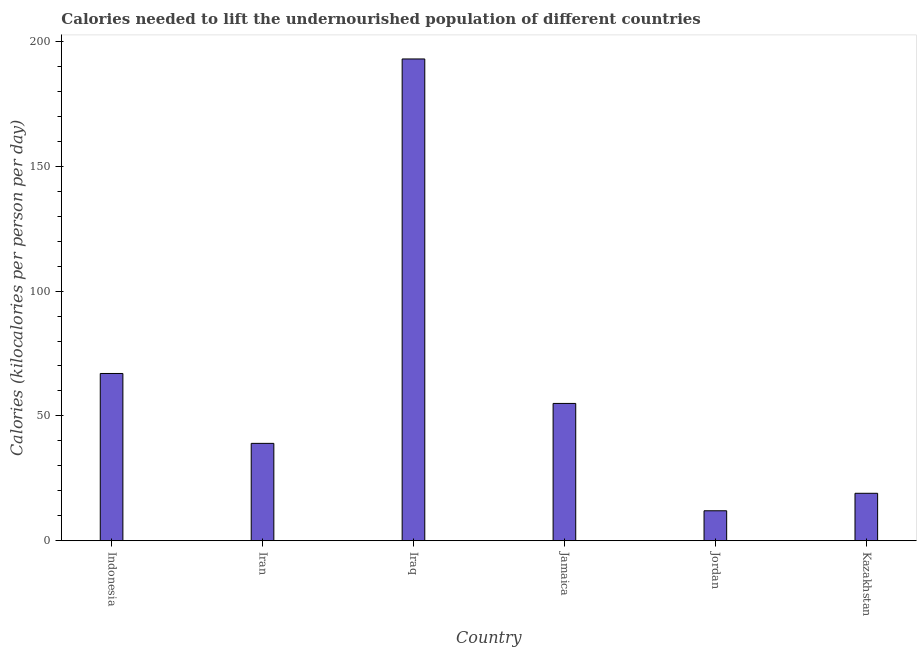What is the title of the graph?
Your answer should be compact. Calories needed to lift the undernourished population of different countries. What is the label or title of the X-axis?
Your answer should be very brief. Country. What is the label or title of the Y-axis?
Make the answer very short. Calories (kilocalories per person per day). What is the depth of food deficit in Jordan?
Your answer should be compact. 12. Across all countries, what is the maximum depth of food deficit?
Provide a succinct answer. 193. Across all countries, what is the minimum depth of food deficit?
Provide a short and direct response. 12. In which country was the depth of food deficit maximum?
Offer a terse response. Iraq. In which country was the depth of food deficit minimum?
Give a very brief answer. Jordan. What is the sum of the depth of food deficit?
Your answer should be compact. 385. What is the average depth of food deficit per country?
Your response must be concise. 64.17. What is the ratio of the depth of food deficit in Iraq to that in Kazakhstan?
Keep it short and to the point. 10.16. Is the depth of food deficit in Indonesia less than that in Iraq?
Make the answer very short. Yes. What is the difference between the highest and the second highest depth of food deficit?
Your answer should be very brief. 126. Is the sum of the depth of food deficit in Iraq and Jamaica greater than the maximum depth of food deficit across all countries?
Provide a short and direct response. Yes. What is the difference between the highest and the lowest depth of food deficit?
Your answer should be compact. 181. In how many countries, is the depth of food deficit greater than the average depth of food deficit taken over all countries?
Provide a succinct answer. 2. How many countries are there in the graph?
Your answer should be very brief. 6. Are the values on the major ticks of Y-axis written in scientific E-notation?
Provide a succinct answer. No. What is the Calories (kilocalories per person per day) of Indonesia?
Provide a short and direct response. 67. What is the Calories (kilocalories per person per day) of Iran?
Provide a short and direct response. 39. What is the Calories (kilocalories per person per day) of Iraq?
Your response must be concise. 193. What is the difference between the Calories (kilocalories per person per day) in Indonesia and Iraq?
Your response must be concise. -126. What is the difference between the Calories (kilocalories per person per day) in Indonesia and Jamaica?
Provide a succinct answer. 12. What is the difference between the Calories (kilocalories per person per day) in Indonesia and Kazakhstan?
Ensure brevity in your answer.  48. What is the difference between the Calories (kilocalories per person per day) in Iran and Iraq?
Your response must be concise. -154. What is the difference between the Calories (kilocalories per person per day) in Iran and Jamaica?
Keep it short and to the point. -16. What is the difference between the Calories (kilocalories per person per day) in Iran and Jordan?
Your answer should be compact. 27. What is the difference between the Calories (kilocalories per person per day) in Iran and Kazakhstan?
Your answer should be compact. 20. What is the difference between the Calories (kilocalories per person per day) in Iraq and Jamaica?
Your answer should be very brief. 138. What is the difference between the Calories (kilocalories per person per day) in Iraq and Jordan?
Ensure brevity in your answer.  181. What is the difference between the Calories (kilocalories per person per day) in Iraq and Kazakhstan?
Keep it short and to the point. 174. What is the difference between the Calories (kilocalories per person per day) in Jamaica and Kazakhstan?
Keep it short and to the point. 36. What is the difference between the Calories (kilocalories per person per day) in Jordan and Kazakhstan?
Provide a succinct answer. -7. What is the ratio of the Calories (kilocalories per person per day) in Indonesia to that in Iran?
Make the answer very short. 1.72. What is the ratio of the Calories (kilocalories per person per day) in Indonesia to that in Iraq?
Your answer should be very brief. 0.35. What is the ratio of the Calories (kilocalories per person per day) in Indonesia to that in Jamaica?
Provide a short and direct response. 1.22. What is the ratio of the Calories (kilocalories per person per day) in Indonesia to that in Jordan?
Your response must be concise. 5.58. What is the ratio of the Calories (kilocalories per person per day) in Indonesia to that in Kazakhstan?
Offer a terse response. 3.53. What is the ratio of the Calories (kilocalories per person per day) in Iran to that in Iraq?
Your answer should be compact. 0.2. What is the ratio of the Calories (kilocalories per person per day) in Iran to that in Jamaica?
Your answer should be very brief. 0.71. What is the ratio of the Calories (kilocalories per person per day) in Iran to that in Jordan?
Your response must be concise. 3.25. What is the ratio of the Calories (kilocalories per person per day) in Iran to that in Kazakhstan?
Offer a terse response. 2.05. What is the ratio of the Calories (kilocalories per person per day) in Iraq to that in Jamaica?
Your answer should be very brief. 3.51. What is the ratio of the Calories (kilocalories per person per day) in Iraq to that in Jordan?
Offer a very short reply. 16.08. What is the ratio of the Calories (kilocalories per person per day) in Iraq to that in Kazakhstan?
Give a very brief answer. 10.16. What is the ratio of the Calories (kilocalories per person per day) in Jamaica to that in Jordan?
Your answer should be compact. 4.58. What is the ratio of the Calories (kilocalories per person per day) in Jamaica to that in Kazakhstan?
Your answer should be compact. 2.9. What is the ratio of the Calories (kilocalories per person per day) in Jordan to that in Kazakhstan?
Offer a very short reply. 0.63. 